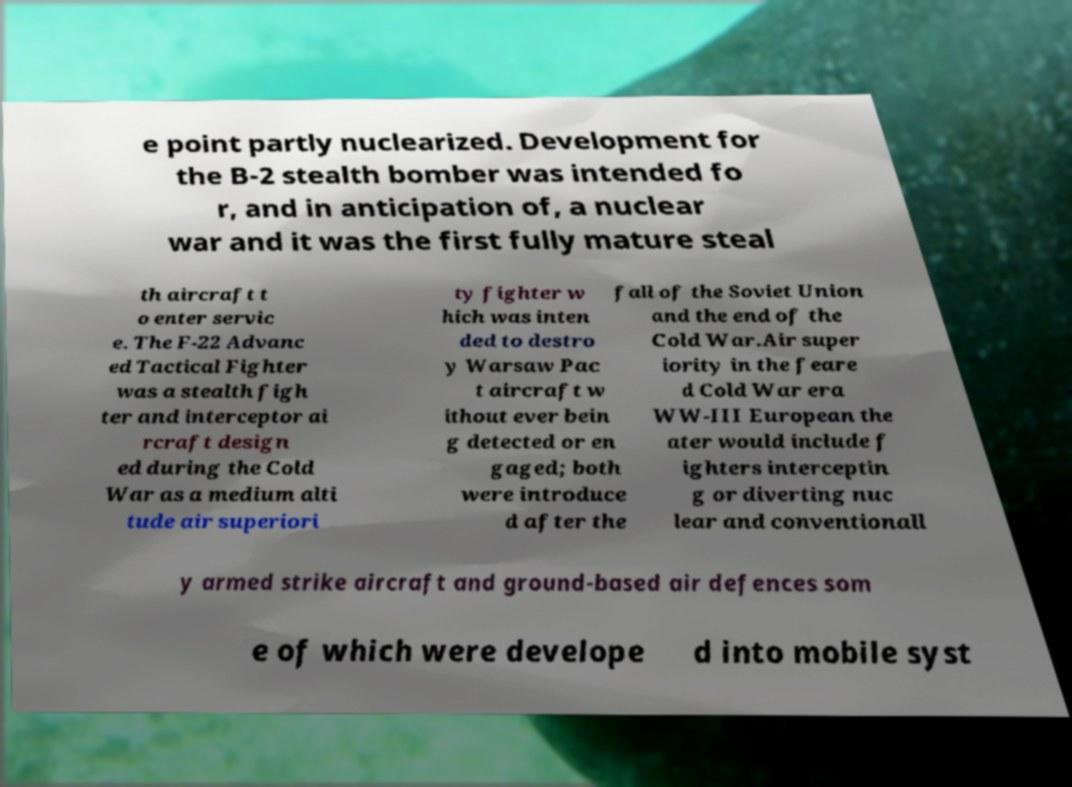For documentation purposes, I need the text within this image transcribed. Could you provide that? e point partly nuclearized. Development for the B-2 stealth bomber was intended fo r, and in anticipation of, a nuclear war and it was the first fully mature steal th aircraft t o enter servic e. The F-22 Advanc ed Tactical Fighter was a stealth figh ter and interceptor ai rcraft design ed during the Cold War as a medium alti tude air superiori ty fighter w hich was inten ded to destro y Warsaw Pac t aircraft w ithout ever bein g detected or en gaged; both were introduce d after the fall of the Soviet Union and the end of the Cold War.Air super iority in the feare d Cold War era WW-III European the ater would include f ighters interceptin g or diverting nuc lear and conventionall y armed strike aircraft and ground-based air defences som e of which were develope d into mobile syst 